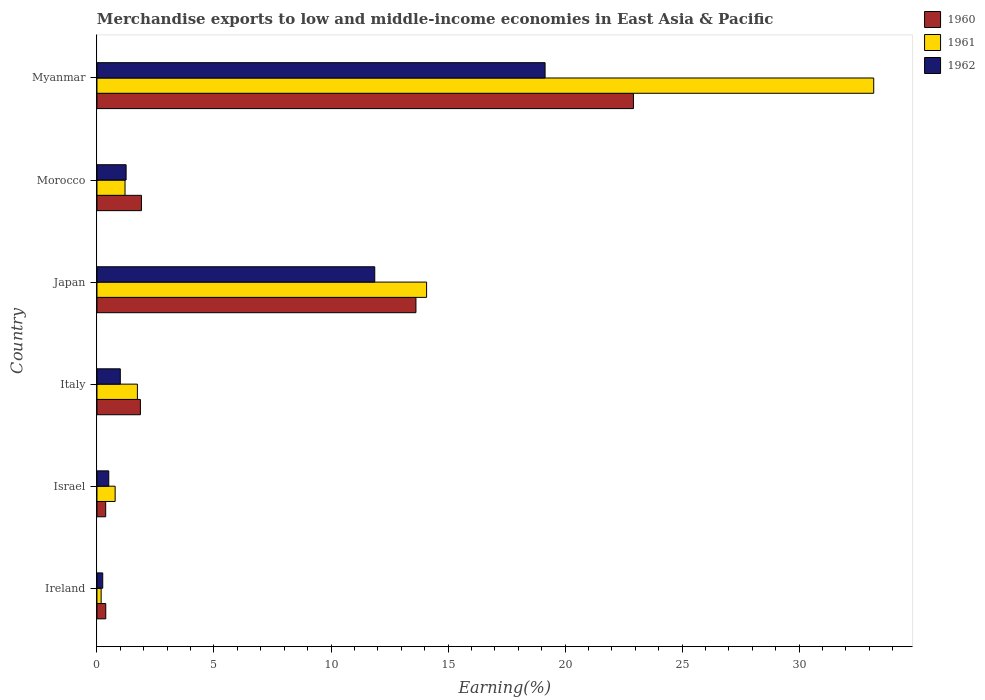How many groups of bars are there?
Your answer should be compact. 6. Are the number of bars on each tick of the Y-axis equal?
Provide a succinct answer. Yes. How many bars are there on the 5th tick from the top?
Ensure brevity in your answer.  3. What is the label of the 6th group of bars from the top?
Provide a succinct answer. Ireland. What is the percentage of amount earned from merchandise exports in 1962 in Morocco?
Offer a terse response. 1.25. Across all countries, what is the maximum percentage of amount earned from merchandise exports in 1960?
Make the answer very short. 22.92. Across all countries, what is the minimum percentage of amount earned from merchandise exports in 1961?
Your answer should be very brief. 0.18. In which country was the percentage of amount earned from merchandise exports in 1961 maximum?
Your answer should be compact. Myanmar. In which country was the percentage of amount earned from merchandise exports in 1961 minimum?
Offer a very short reply. Ireland. What is the total percentage of amount earned from merchandise exports in 1961 in the graph?
Provide a succinct answer. 51.16. What is the difference between the percentage of amount earned from merchandise exports in 1962 in Japan and that in Morocco?
Provide a succinct answer. 10.62. What is the difference between the percentage of amount earned from merchandise exports in 1960 in Japan and the percentage of amount earned from merchandise exports in 1962 in Ireland?
Make the answer very short. 13.38. What is the average percentage of amount earned from merchandise exports in 1960 per country?
Provide a short and direct response. 6.84. What is the difference between the percentage of amount earned from merchandise exports in 1960 and percentage of amount earned from merchandise exports in 1962 in Japan?
Provide a short and direct response. 1.76. What is the ratio of the percentage of amount earned from merchandise exports in 1960 in Ireland to that in Israel?
Provide a succinct answer. 1.01. Is the percentage of amount earned from merchandise exports in 1960 in Israel less than that in Japan?
Ensure brevity in your answer.  Yes. What is the difference between the highest and the second highest percentage of amount earned from merchandise exports in 1961?
Ensure brevity in your answer.  19.11. What is the difference between the highest and the lowest percentage of amount earned from merchandise exports in 1962?
Provide a short and direct response. 18.9. In how many countries, is the percentage of amount earned from merchandise exports in 1962 greater than the average percentage of amount earned from merchandise exports in 1962 taken over all countries?
Your answer should be very brief. 2. What does the 3rd bar from the top in Ireland represents?
Provide a succinct answer. 1960. Is it the case that in every country, the sum of the percentage of amount earned from merchandise exports in 1960 and percentage of amount earned from merchandise exports in 1962 is greater than the percentage of amount earned from merchandise exports in 1961?
Make the answer very short. Yes. Are all the bars in the graph horizontal?
Provide a short and direct response. Yes. What is the difference between two consecutive major ticks on the X-axis?
Offer a very short reply. 5. Does the graph contain any zero values?
Offer a terse response. No. Does the graph contain grids?
Your answer should be compact. No. What is the title of the graph?
Provide a short and direct response. Merchandise exports to low and middle-income economies in East Asia & Pacific. Does "2010" appear as one of the legend labels in the graph?
Give a very brief answer. No. What is the label or title of the X-axis?
Keep it short and to the point. Earning(%). What is the label or title of the Y-axis?
Your response must be concise. Country. What is the Earning(%) of 1960 in Ireland?
Your answer should be compact. 0.38. What is the Earning(%) of 1961 in Ireland?
Provide a short and direct response. 0.18. What is the Earning(%) in 1962 in Ireland?
Ensure brevity in your answer.  0.25. What is the Earning(%) in 1960 in Israel?
Offer a very short reply. 0.37. What is the Earning(%) of 1961 in Israel?
Make the answer very short. 0.78. What is the Earning(%) in 1962 in Israel?
Your answer should be compact. 0.5. What is the Earning(%) in 1960 in Italy?
Your answer should be compact. 1.86. What is the Earning(%) in 1961 in Italy?
Provide a short and direct response. 1.73. What is the Earning(%) of 1962 in Italy?
Give a very brief answer. 1. What is the Earning(%) in 1960 in Japan?
Your answer should be very brief. 13.63. What is the Earning(%) in 1961 in Japan?
Your answer should be very brief. 14.09. What is the Earning(%) in 1962 in Japan?
Your answer should be very brief. 11.87. What is the Earning(%) in 1960 in Morocco?
Make the answer very short. 1.9. What is the Earning(%) in 1961 in Morocco?
Give a very brief answer. 1.2. What is the Earning(%) of 1962 in Morocco?
Give a very brief answer. 1.25. What is the Earning(%) of 1960 in Myanmar?
Ensure brevity in your answer.  22.92. What is the Earning(%) of 1961 in Myanmar?
Give a very brief answer. 33.19. What is the Earning(%) of 1962 in Myanmar?
Ensure brevity in your answer.  19.15. Across all countries, what is the maximum Earning(%) in 1960?
Your response must be concise. 22.92. Across all countries, what is the maximum Earning(%) in 1961?
Your answer should be very brief. 33.19. Across all countries, what is the maximum Earning(%) in 1962?
Offer a very short reply. 19.15. Across all countries, what is the minimum Earning(%) of 1960?
Your answer should be compact. 0.37. Across all countries, what is the minimum Earning(%) in 1961?
Make the answer very short. 0.18. Across all countries, what is the minimum Earning(%) in 1962?
Make the answer very short. 0.25. What is the total Earning(%) in 1960 in the graph?
Offer a terse response. 41.06. What is the total Earning(%) of 1961 in the graph?
Provide a short and direct response. 51.16. What is the total Earning(%) of 1962 in the graph?
Provide a succinct answer. 34.01. What is the difference between the Earning(%) in 1960 in Ireland and that in Israel?
Your response must be concise. 0. What is the difference between the Earning(%) in 1961 in Ireland and that in Israel?
Make the answer very short. -0.6. What is the difference between the Earning(%) in 1962 in Ireland and that in Israel?
Ensure brevity in your answer.  -0.26. What is the difference between the Earning(%) in 1960 in Ireland and that in Italy?
Provide a short and direct response. -1.48. What is the difference between the Earning(%) in 1961 in Ireland and that in Italy?
Ensure brevity in your answer.  -1.55. What is the difference between the Earning(%) in 1962 in Ireland and that in Italy?
Keep it short and to the point. -0.75. What is the difference between the Earning(%) in 1960 in Ireland and that in Japan?
Your answer should be very brief. -13.25. What is the difference between the Earning(%) of 1961 in Ireland and that in Japan?
Give a very brief answer. -13.91. What is the difference between the Earning(%) of 1962 in Ireland and that in Japan?
Provide a succinct answer. -11.62. What is the difference between the Earning(%) in 1960 in Ireland and that in Morocco?
Ensure brevity in your answer.  -1.52. What is the difference between the Earning(%) of 1961 in Ireland and that in Morocco?
Offer a terse response. -1.02. What is the difference between the Earning(%) in 1962 in Ireland and that in Morocco?
Provide a succinct answer. -1. What is the difference between the Earning(%) of 1960 in Ireland and that in Myanmar?
Provide a succinct answer. -22.55. What is the difference between the Earning(%) in 1961 in Ireland and that in Myanmar?
Give a very brief answer. -33.01. What is the difference between the Earning(%) of 1962 in Ireland and that in Myanmar?
Offer a terse response. -18.9. What is the difference between the Earning(%) of 1960 in Israel and that in Italy?
Your response must be concise. -1.48. What is the difference between the Earning(%) of 1961 in Israel and that in Italy?
Your response must be concise. -0.95. What is the difference between the Earning(%) of 1962 in Israel and that in Italy?
Keep it short and to the point. -0.49. What is the difference between the Earning(%) in 1960 in Israel and that in Japan?
Provide a short and direct response. -13.26. What is the difference between the Earning(%) of 1961 in Israel and that in Japan?
Keep it short and to the point. -13.31. What is the difference between the Earning(%) of 1962 in Israel and that in Japan?
Give a very brief answer. -11.37. What is the difference between the Earning(%) of 1960 in Israel and that in Morocco?
Give a very brief answer. -1.53. What is the difference between the Earning(%) of 1961 in Israel and that in Morocco?
Ensure brevity in your answer.  -0.42. What is the difference between the Earning(%) of 1962 in Israel and that in Morocco?
Provide a short and direct response. -0.74. What is the difference between the Earning(%) of 1960 in Israel and that in Myanmar?
Your answer should be very brief. -22.55. What is the difference between the Earning(%) of 1961 in Israel and that in Myanmar?
Provide a succinct answer. -32.41. What is the difference between the Earning(%) in 1962 in Israel and that in Myanmar?
Offer a very short reply. -18.64. What is the difference between the Earning(%) in 1960 in Italy and that in Japan?
Give a very brief answer. -11.77. What is the difference between the Earning(%) of 1961 in Italy and that in Japan?
Give a very brief answer. -12.36. What is the difference between the Earning(%) in 1962 in Italy and that in Japan?
Keep it short and to the point. -10.87. What is the difference between the Earning(%) in 1960 in Italy and that in Morocco?
Offer a very short reply. -0.04. What is the difference between the Earning(%) in 1961 in Italy and that in Morocco?
Provide a short and direct response. 0.53. What is the difference between the Earning(%) of 1962 in Italy and that in Morocco?
Make the answer very short. -0.25. What is the difference between the Earning(%) in 1960 in Italy and that in Myanmar?
Provide a short and direct response. -21.07. What is the difference between the Earning(%) in 1961 in Italy and that in Myanmar?
Ensure brevity in your answer.  -31.46. What is the difference between the Earning(%) of 1962 in Italy and that in Myanmar?
Ensure brevity in your answer.  -18.15. What is the difference between the Earning(%) in 1960 in Japan and that in Morocco?
Offer a terse response. 11.73. What is the difference between the Earning(%) in 1961 in Japan and that in Morocco?
Provide a succinct answer. 12.89. What is the difference between the Earning(%) of 1962 in Japan and that in Morocco?
Your answer should be very brief. 10.62. What is the difference between the Earning(%) in 1960 in Japan and that in Myanmar?
Make the answer very short. -9.29. What is the difference between the Earning(%) in 1961 in Japan and that in Myanmar?
Provide a short and direct response. -19.11. What is the difference between the Earning(%) of 1962 in Japan and that in Myanmar?
Ensure brevity in your answer.  -7.28. What is the difference between the Earning(%) in 1960 in Morocco and that in Myanmar?
Offer a very short reply. -21.02. What is the difference between the Earning(%) of 1961 in Morocco and that in Myanmar?
Your response must be concise. -31.99. What is the difference between the Earning(%) in 1962 in Morocco and that in Myanmar?
Your answer should be compact. -17.9. What is the difference between the Earning(%) of 1960 in Ireland and the Earning(%) of 1961 in Israel?
Offer a very short reply. -0.4. What is the difference between the Earning(%) of 1960 in Ireland and the Earning(%) of 1962 in Israel?
Give a very brief answer. -0.13. What is the difference between the Earning(%) in 1961 in Ireland and the Earning(%) in 1962 in Israel?
Ensure brevity in your answer.  -0.33. What is the difference between the Earning(%) in 1960 in Ireland and the Earning(%) in 1961 in Italy?
Ensure brevity in your answer.  -1.35. What is the difference between the Earning(%) in 1960 in Ireland and the Earning(%) in 1962 in Italy?
Keep it short and to the point. -0.62. What is the difference between the Earning(%) of 1961 in Ireland and the Earning(%) of 1962 in Italy?
Your answer should be very brief. -0.82. What is the difference between the Earning(%) in 1960 in Ireland and the Earning(%) in 1961 in Japan?
Offer a terse response. -13.71. What is the difference between the Earning(%) of 1960 in Ireland and the Earning(%) of 1962 in Japan?
Give a very brief answer. -11.49. What is the difference between the Earning(%) of 1961 in Ireland and the Earning(%) of 1962 in Japan?
Provide a succinct answer. -11.69. What is the difference between the Earning(%) in 1960 in Ireland and the Earning(%) in 1961 in Morocco?
Your answer should be very brief. -0.82. What is the difference between the Earning(%) in 1960 in Ireland and the Earning(%) in 1962 in Morocco?
Keep it short and to the point. -0.87. What is the difference between the Earning(%) of 1961 in Ireland and the Earning(%) of 1962 in Morocco?
Your answer should be compact. -1.07. What is the difference between the Earning(%) in 1960 in Ireland and the Earning(%) in 1961 in Myanmar?
Your answer should be very brief. -32.81. What is the difference between the Earning(%) of 1960 in Ireland and the Earning(%) of 1962 in Myanmar?
Offer a terse response. -18.77. What is the difference between the Earning(%) in 1961 in Ireland and the Earning(%) in 1962 in Myanmar?
Ensure brevity in your answer.  -18.97. What is the difference between the Earning(%) in 1960 in Israel and the Earning(%) in 1961 in Italy?
Provide a succinct answer. -1.36. What is the difference between the Earning(%) in 1960 in Israel and the Earning(%) in 1962 in Italy?
Ensure brevity in your answer.  -0.63. What is the difference between the Earning(%) in 1961 in Israel and the Earning(%) in 1962 in Italy?
Offer a very short reply. -0.22. What is the difference between the Earning(%) of 1960 in Israel and the Earning(%) of 1961 in Japan?
Provide a short and direct response. -13.71. What is the difference between the Earning(%) of 1960 in Israel and the Earning(%) of 1962 in Japan?
Provide a succinct answer. -11.5. What is the difference between the Earning(%) in 1961 in Israel and the Earning(%) in 1962 in Japan?
Make the answer very short. -11.09. What is the difference between the Earning(%) in 1960 in Israel and the Earning(%) in 1961 in Morocco?
Offer a terse response. -0.83. What is the difference between the Earning(%) of 1960 in Israel and the Earning(%) of 1962 in Morocco?
Provide a short and direct response. -0.87. What is the difference between the Earning(%) in 1961 in Israel and the Earning(%) in 1962 in Morocco?
Give a very brief answer. -0.47. What is the difference between the Earning(%) in 1960 in Israel and the Earning(%) in 1961 in Myanmar?
Your answer should be compact. -32.82. What is the difference between the Earning(%) in 1960 in Israel and the Earning(%) in 1962 in Myanmar?
Offer a terse response. -18.78. What is the difference between the Earning(%) of 1961 in Israel and the Earning(%) of 1962 in Myanmar?
Make the answer very short. -18.37. What is the difference between the Earning(%) of 1960 in Italy and the Earning(%) of 1961 in Japan?
Provide a short and direct response. -12.23. What is the difference between the Earning(%) in 1960 in Italy and the Earning(%) in 1962 in Japan?
Give a very brief answer. -10.01. What is the difference between the Earning(%) in 1961 in Italy and the Earning(%) in 1962 in Japan?
Ensure brevity in your answer.  -10.14. What is the difference between the Earning(%) in 1960 in Italy and the Earning(%) in 1961 in Morocco?
Provide a succinct answer. 0.66. What is the difference between the Earning(%) in 1960 in Italy and the Earning(%) in 1962 in Morocco?
Keep it short and to the point. 0.61. What is the difference between the Earning(%) in 1961 in Italy and the Earning(%) in 1962 in Morocco?
Keep it short and to the point. 0.48. What is the difference between the Earning(%) of 1960 in Italy and the Earning(%) of 1961 in Myanmar?
Your response must be concise. -31.33. What is the difference between the Earning(%) in 1960 in Italy and the Earning(%) in 1962 in Myanmar?
Provide a succinct answer. -17.29. What is the difference between the Earning(%) of 1961 in Italy and the Earning(%) of 1962 in Myanmar?
Offer a terse response. -17.42. What is the difference between the Earning(%) in 1960 in Japan and the Earning(%) in 1961 in Morocco?
Offer a very short reply. 12.43. What is the difference between the Earning(%) in 1960 in Japan and the Earning(%) in 1962 in Morocco?
Keep it short and to the point. 12.38. What is the difference between the Earning(%) of 1961 in Japan and the Earning(%) of 1962 in Morocco?
Make the answer very short. 12.84. What is the difference between the Earning(%) of 1960 in Japan and the Earning(%) of 1961 in Myanmar?
Offer a very short reply. -19.56. What is the difference between the Earning(%) of 1960 in Japan and the Earning(%) of 1962 in Myanmar?
Your answer should be compact. -5.52. What is the difference between the Earning(%) in 1961 in Japan and the Earning(%) in 1962 in Myanmar?
Give a very brief answer. -5.06. What is the difference between the Earning(%) in 1960 in Morocco and the Earning(%) in 1961 in Myanmar?
Keep it short and to the point. -31.29. What is the difference between the Earning(%) of 1960 in Morocco and the Earning(%) of 1962 in Myanmar?
Your answer should be compact. -17.25. What is the difference between the Earning(%) in 1961 in Morocco and the Earning(%) in 1962 in Myanmar?
Make the answer very short. -17.95. What is the average Earning(%) in 1960 per country?
Give a very brief answer. 6.84. What is the average Earning(%) in 1961 per country?
Ensure brevity in your answer.  8.53. What is the average Earning(%) in 1962 per country?
Provide a succinct answer. 5.67. What is the difference between the Earning(%) of 1960 and Earning(%) of 1961 in Ireland?
Provide a short and direct response. 0.2. What is the difference between the Earning(%) in 1960 and Earning(%) in 1962 in Ireland?
Provide a succinct answer. 0.13. What is the difference between the Earning(%) of 1961 and Earning(%) of 1962 in Ireland?
Give a very brief answer. -0.07. What is the difference between the Earning(%) of 1960 and Earning(%) of 1961 in Israel?
Your answer should be very brief. -0.4. What is the difference between the Earning(%) in 1960 and Earning(%) in 1962 in Israel?
Keep it short and to the point. -0.13. What is the difference between the Earning(%) in 1961 and Earning(%) in 1962 in Israel?
Your response must be concise. 0.27. What is the difference between the Earning(%) of 1960 and Earning(%) of 1961 in Italy?
Your answer should be very brief. 0.13. What is the difference between the Earning(%) in 1960 and Earning(%) in 1962 in Italy?
Make the answer very short. 0.86. What is the difference between the Earning(%) of 1961 and Earning(%) of 1962 in Italy?
Offer a terse response. 0.73. What is the difference between the Earning(%) in 1960 and Earning(%) in 1961 in Japan?
Keep it short and to the point. -0.46. What is the difference between the Earning(%) in 1960 and Earning(%) in 1962 in Japan?
Your answer should be compact. 1.76. What is the difference between the Earning(%) in 1961 and Earning(%) in 1962 in Japan?
Give a very brief answer. 2.22. What is the difference between the Earning(%) of 1960 and Earning(%) of 1961 in Morocco?
Keep it short and to the point. 0.7. What is the difference between the Earning(%) in 1960 and Earning(%) in 1962 in Morocco?
Offer a terse response. 0.66. What is the difference between the Earning(%) of 1961 and Earning(%) of 1962 in Morocco?
Give a very brief answer. -0.05. What is the difference between the Earning(%) in 1960 and Earning(%) in 1961 in Myanmar?
Provide a short and direct response. -10.27. What is the difference between the Earning(%) in 1960 and Earning(%) in 1962 in Myanmar?
Give a very brief answer. 3.78. What is the difference between the Earning(%) of 1961 and Earning(%) of 1962 in Myanmar?
Offer a terse response. 14.04. What is the ratio of the Earning(%) of 1960 in Ireland to that in Israel?
Your answer should be compact. 1.01. What is the ratio of the Earning(%) in 1961 in Ireland to that in Israel?
Give a very brief answer. 0.23. What is the ratio of the Earning(%) of 1962 in Ireland to that in Israel?
Make the answer very short. 0.49. What is the ratio of the Earning(%) in 1960 in Ireland to that in Italy?
Provide a short and direct response. 0.2. What is the ratio of the Earning(%) in 1961 in Ireland to that in Italy?
Offer a very short reply. 0.1. What is the ratio of the Earning(%) of 1962 in Ireland to that in Italy?
Make the answer very short. 0.25. What is the ratio of the Earning(%) in 1960 in Ireland to that in Japan?
Your answer should be very brief. 0.03. What is the ratio of the Earning(%) of 1961 in Ireland to that in Japan?
Offer a very short reply. 0.01. What is the ratio of the Earning(%) of 1962 in Ireland to that in Japan?
Make the answer very short. 0.02. What is the ratio of the Earning(%) in 1960 in Ireland to that in Morocco?
Offer a terse response. 0.2. What is the ratio of the Earning(%) of 1961 in Ireland to that in Morocco?
Keep it short and to the point. 0.15. What is the ratio of the Earning(%) of 1962 in Ireland to that in Morocco?
Keep it short and to the point. 0.2. What is the ratio of the Earning(%) in 1960 in Ireland to that in Myanmar?
Offer a terse response. 0.02. What is the ratio of the Earning(%) in 1961 in Ireland to that in Myanmar?
Your response must be concise. 0.01. What is the ratio of the Earning(%) in 1962 in Ireland to that in Myanmar?
Make the answer very short. 0.01. What is the ratio of the Earning(%) in 1960 in Israel to that in Italy?
Provide a succinct answer. 0.2. What is the ratio of the Earning(%) in 1961 in Israel to that in Italy?
Your response must be concise. 0.45. What is the ratio of the Earning(%) of 1962 in Israel to that in Italy?
Give a very brief answer. 0.51. What is the ratio of the Earning(%) in 1960 in Israel to that in Japan?
Make the answer very short. 0.03. What is the ratio of the Earning(%) of 1961 in Israel to that in Japan?
Your answer should be compact. 0.06. What is the ratio of the Earning(%) of 1962 in Israel to that in Japan?
Your answer should be very brief. 0.04. What is the ratio of the Earning(%) of 1960 in Israel to that in Morocco?
Provide a succinct answer. 0.2. What is the ratio of the Earning(%) of 1961 in Israel to that in Morocco?
Your response must be concise. 0.65. What is the ratio of the Earning(%) in 1962 in Israel to that in Morocco?
Your answer should be compact. 0.4. What is the ratio of the Earning(%) of 1960 in Israel to that in Myanmar?
Your response must be concise. 0.02. What is the ratio of the Earning(%) of 1961 in Israel to that in Myanmar?
Offer a terse response. 0.02. What is the ratio of the Earning(%) in 1962 in Israel to that in Myanmar?
Your answer should be compact. 0.03. What is the ratio of the Earning(%) in 1960 in Italy to that in Japan?
Ensure brevity in your answer.  0.14. What is the ratio of the Earning(%) of 1961 in Italy to that in Japan?
Offer a very short reply. 0.12. What is the ratio of the Earning(%) of 1962 in Italy to that in Japan?
Give a very brief answer. 0.08. What is the ratio of the Earning(%) in 1960 in Italy to that in Morocco?
Your response must be concise. 0.98. What is the ratio of the Earning(%) of 1961 in Italy to that in Morocco?
Give a very brief answer. 1.44. What is the ratio of the Earning(%) of 1962 in Italy to that in Morocco?
Provide a short and direct response. 0.8. What is the ratio of the Earning(%) in 1960 in Italy to that in Myanmar?
Ensure brevity in your answer.  0.08. What is the ratio of the Earning(%) in 1961 in Italy to that in Myanmar?
Offer a terse response. 0.05. What is the ratio of the Earning(%) of 1962 in Italy to that in Myanmar?
Offer a terse response. 0.05. What is the ratio of the Earning(%) of 1960 in Japan to that in Morocco?
Ensure brevity in your answer.  7.17. What is the ratio of the Earning(%) of 1961 in Japan to that in Morocco?
Offer a very short reply. 11.75. What is the ratio of the Earning(%) of 1962 in Japan to that in Morocco?
Offer a very short reply. 9.53. What is the ratio of the Earning(%) of 1960 in Japan to that in Myanmar?
Make the answer very short. 0.59. What is the ratio of the Earning(%) in 1961 in Japan to that in Myanmar?
Your answer should be very brief. 0.42. What is the ratio of the Earning(%) of 1962 in Japan to that in Myanmar?
Your response must be concise. 0.62. What is the ratio of the Earning(%) of 1960 in Morocco to that in Myanmar?
Make the answer very short. 0.08. What is the ratio of the Earning(%) in 1961 in Morocco to that in Myanmar?
Your response must be concise. 0.04. What is the ratio of the Earning(%) of 1962 in Morocco to that in Myanmar?
Give a very brief answer. 0.07. What is the difference between the highest and the second highest Earning(%) of 1960?
Ensure brevity in your answer.  9.29. What is the difference between the highest and the second highest Earning(%) in 1961?
Keep it short and to the point. 19.11. What is the difference between the highest and the second highest Earning(%) of 1962?
Provide a succinct answer. 7.28. What is the difference between the highest and the lowest Earning(%) in 1960?
Offer a terse response. 22.55. What is the difference between the highest and the lowest Earning(%) of 1961?
Provide a succinct answer. 33.01. What is the difference between the highest and the lowest Earning(%) of 1962?
Offer a terse response. 18.9. 